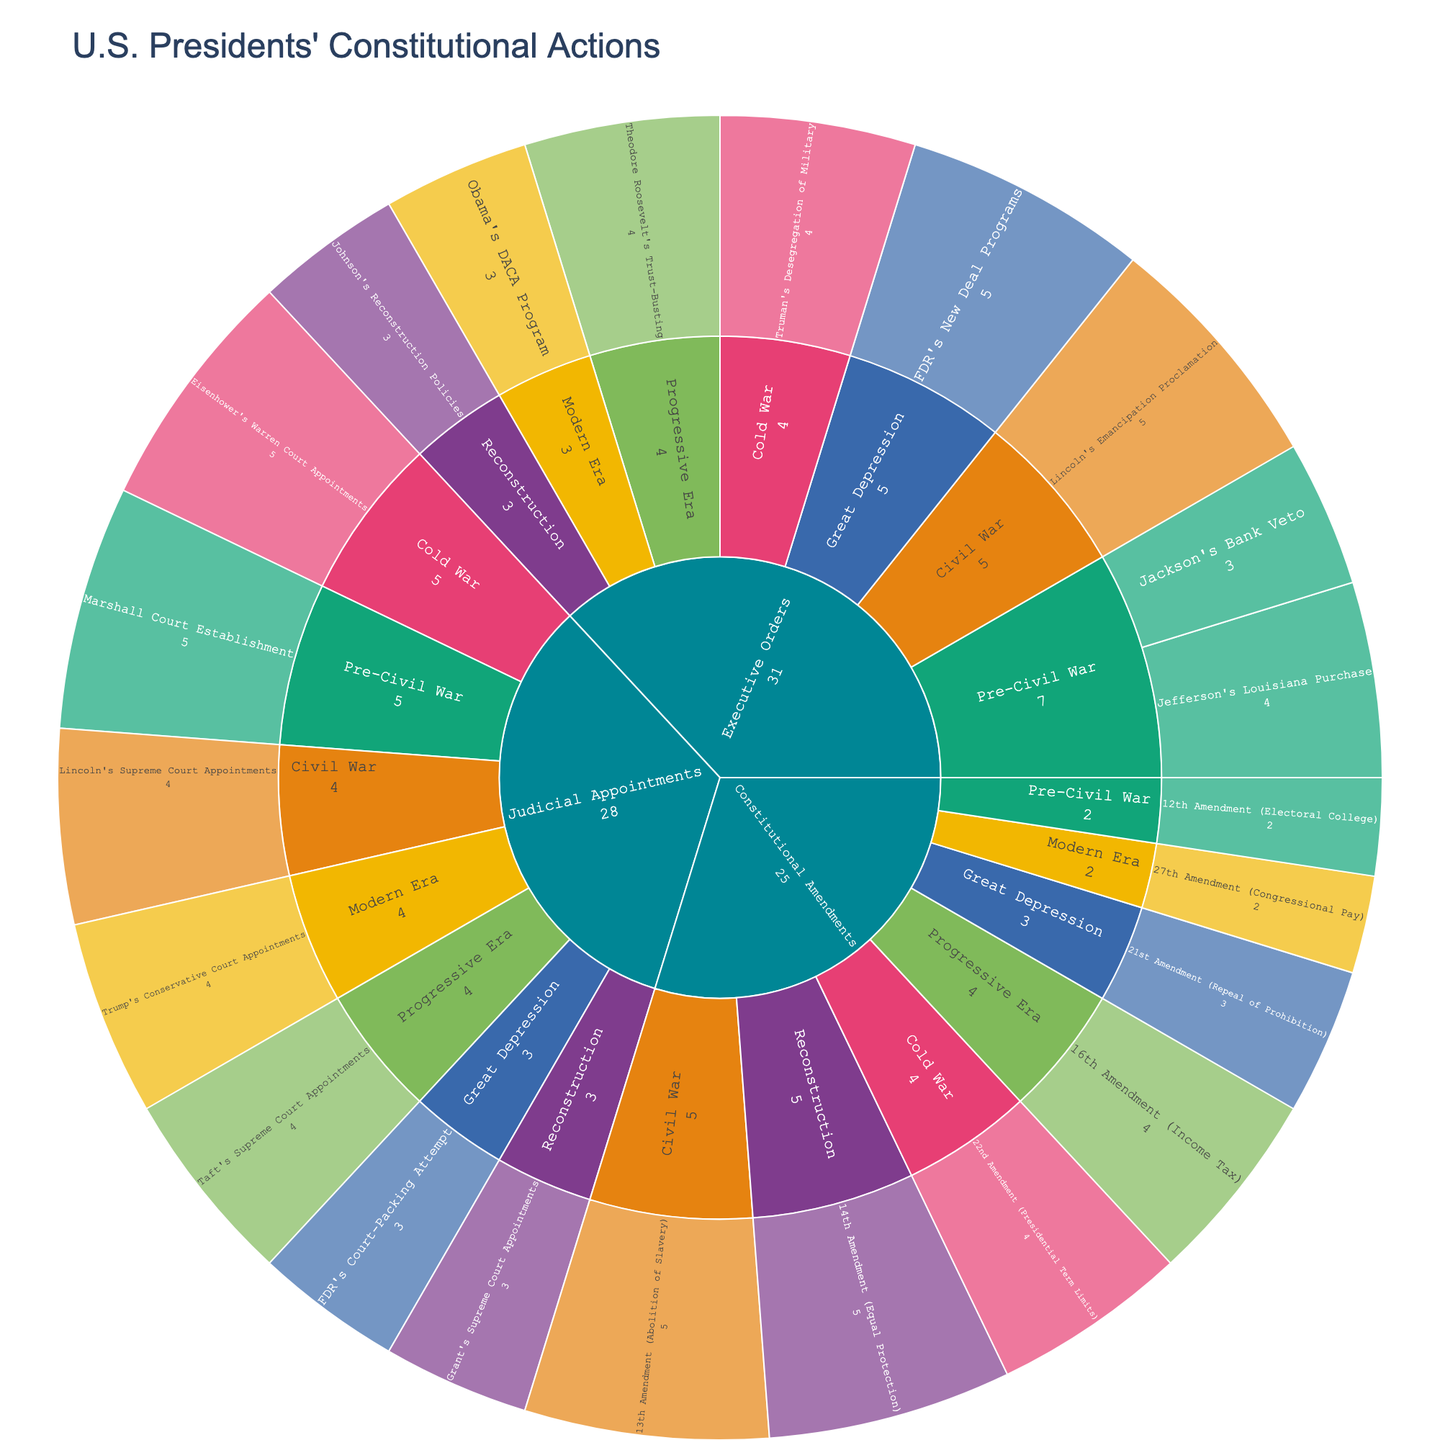What's the title of the sunburst plot? The title of the plot is found at the top of the figure. It is specified in large, bold text to capture attention.
Answer: U.S. Presidents' Constitutional Actions What categories are used in the sunburst plot? The first level of the sunburst plot is divided into different categories. These categories are Executive Orders, Constitutional Amendments, and Judicial Appointments.
Answer: Executive Orders, Constitutional Amendments, Judicial Appointments Which era has the highest impact value for Executive Orders? Within the Executive Orders category, look at the different eras and their associated impact values. The era with the highest single impact value for an Executive Order will be the answer.
Answer: Civil War (Lincoln's Emancipation Proclamation) How does the impact of the 13th Amendment compare to the 27th Amendment? Examine the impact values for each amendment within the Constitutional Amendments category. This requires a comparison of the values to determine which is higher or lower.
Answer: The 13th Amendment has a higher impact value than the 27th Amendment. (5 vs. 2) Which action has the highest impact in the Great Depression era? Look within the Great Depression slice and identify the action with the highest impact value. Each action within an era is displayed with its respective impact.
Answer: FDR's New Deal Programs Compare the impact of actions in the Cold War era for Executive Orders and Judicial Appointments. Examine the Cold War sections within both the Executive Orders and Judicial Appointments categories. Compare the highest impact values in each to determine which is higher.
Answer: Judicial Appointments (Eisenhower's Warren Court Appointments, impact 5 vs. Truman's Desegregation of Military, impact 4) How many actions have an impact value of 5 in the sunburst plot? Identify all actions throughout the plot with an impact value of 5. Count each of these actions to get the total number.
Answer: 5 Which era includes the Jackson's Bank Veto and what is its impact? Locate Jackson's Bank Veto in the plot, identify its era, and note its impact value. The plot is organized by era, which simplifies finding this action.
Answer: Pre-Civil War, impact 3 Calculate the average impact of Judicial Appointments. To find the average, sum the impact values of all Judicial Appointments and divide by the number of Judicial Appointment actions. The values are 5, 4, 3, 4, 3, 5, and 4. Sum is 28 divided by 7 actions.
Answer: 4 